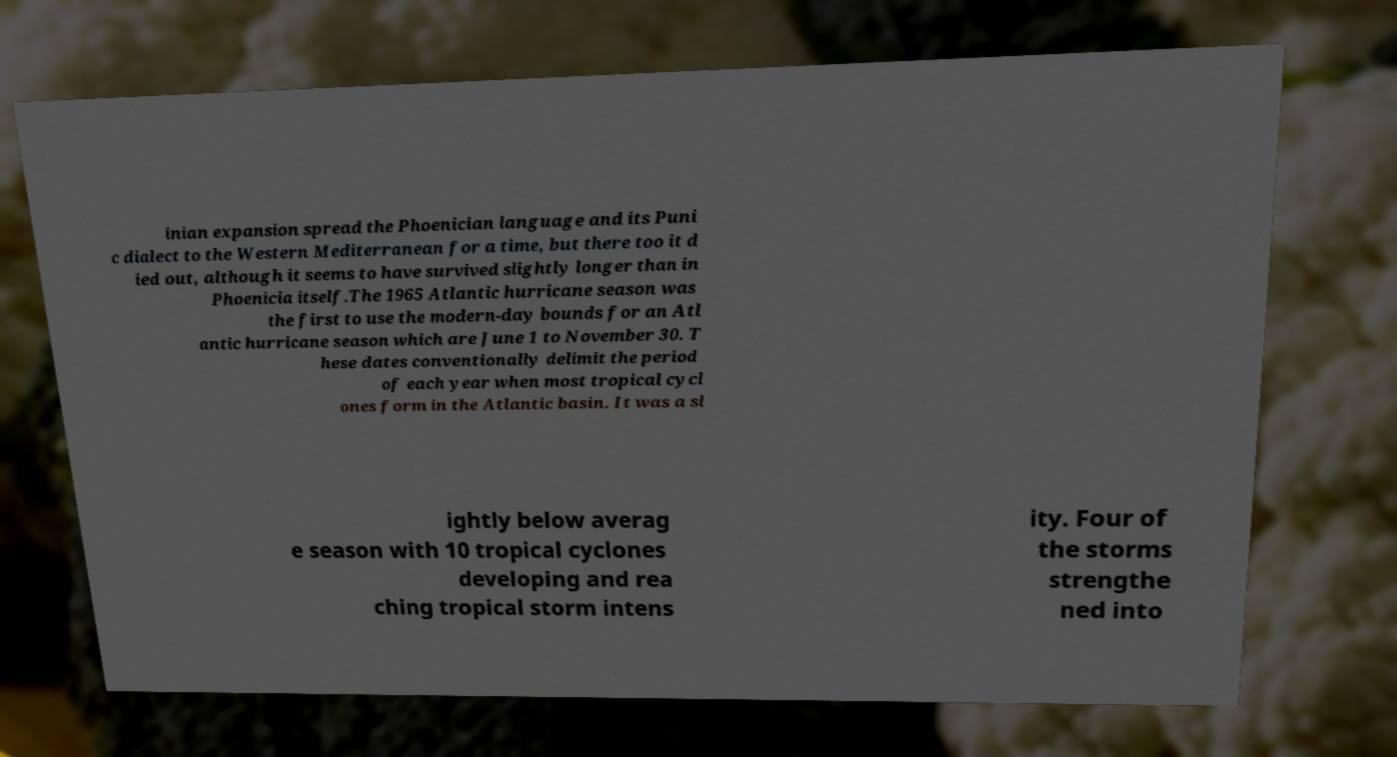What messages or text are displayed in this image? I need them in a readable, typed format. inian expansion spread the Phoenician language and its Puni c dialect to the Western Mediterranean for a time, but there too it d ied out, although it seems to have survived slightly longer than in Phoenicia itself.The 1965 Atlantic hurricane season was the first to use the modern-day bounds for an Atl antic hurricane season which are June 1 to November 30. T hese dates conventionally delimit the period of each year when most tropical cycl ones form in the Atlantic basin. It was a sl ightly below averag e season with 10 tropical cyclones developing and rea ching tropical storm intens ity. Four of the storms strengthe ned into 